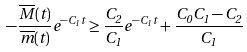Convert formula to latex. <formula><loc_0><loc_0><loc_500><loc_500>- \frac { \overline { M } ( t ) } { \overline { m } ( t ) } e ^ { - C _ { 1 } \, t } \geq \frac { C _ { 2 } } { C _ { 1 } } e ^ { - C _ { 1 } \, t } + \frac { C _ { 0 } C _ { 1 } - C _ { 2 } } { C _ { 1 } }</formula> 